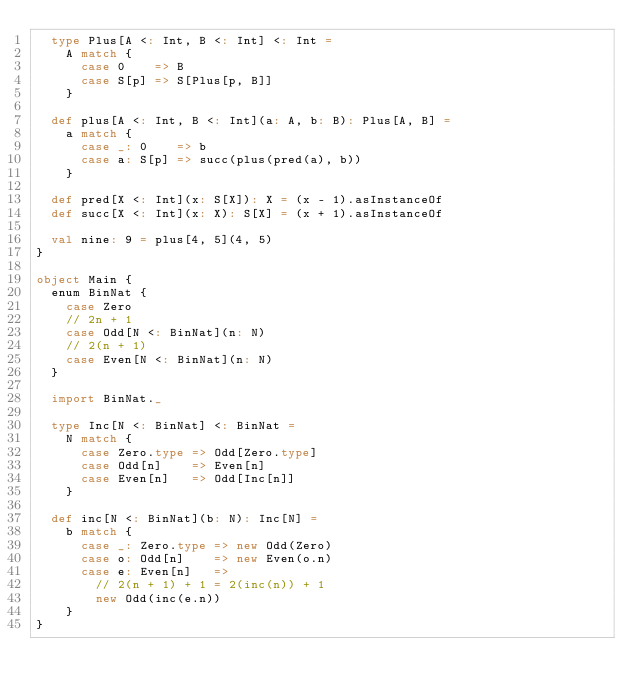<code> <loc_0><loc_0><loc_500><loc_500><_Scala_>  type Plus[A <: Int, B <: Int] <: Int =
    A match {
      case 0    => B
      case S[p] => S[Plus[p, B]]
    }

  def plus[A <: Int, B <: Int](a: A, b: B): Plus[A, B] =
    a match {
      case _: 0    => b
      case a: S[p] => succ(plus(pred(a), b))
    }

  def pred[X <: Int](x: S[X]): X = (x - 1).asInstanceOf
  def succ[X <: Int](x: X): S[X] = (x + 1).asInstanceOf

  val nine: 9 = plus[4, 5](4, 5)
}

object Main {
  enum BinNat {
    case Zero
    // 2n + 1
    case Odd[N <: BinNat](n: N)
    // 2(n + 1)
    case Even[N <: BinNat](n: N)
  }

  import BinNat._

  type Inc[N <: BinNat] <: BinNat =
    N match {
      case Zero.type => Odd[Zero.type]
      case Odd[n]    => Even[n]
      case Even[n]   => Odd[Inc[n]]
    }

  def inc[N <: BinNat](b: N): Inc[N] =
    b match {
      case _: Zero.type => new Odd(Zero)
      case o: Odd[n]    => new Even(o.n)
      case e: Even[n]   =>
        // 2(n + 1) + 1 = 2(inc(n)) + 1
        new Odd(inc(e.n))
    }
}
</code> 